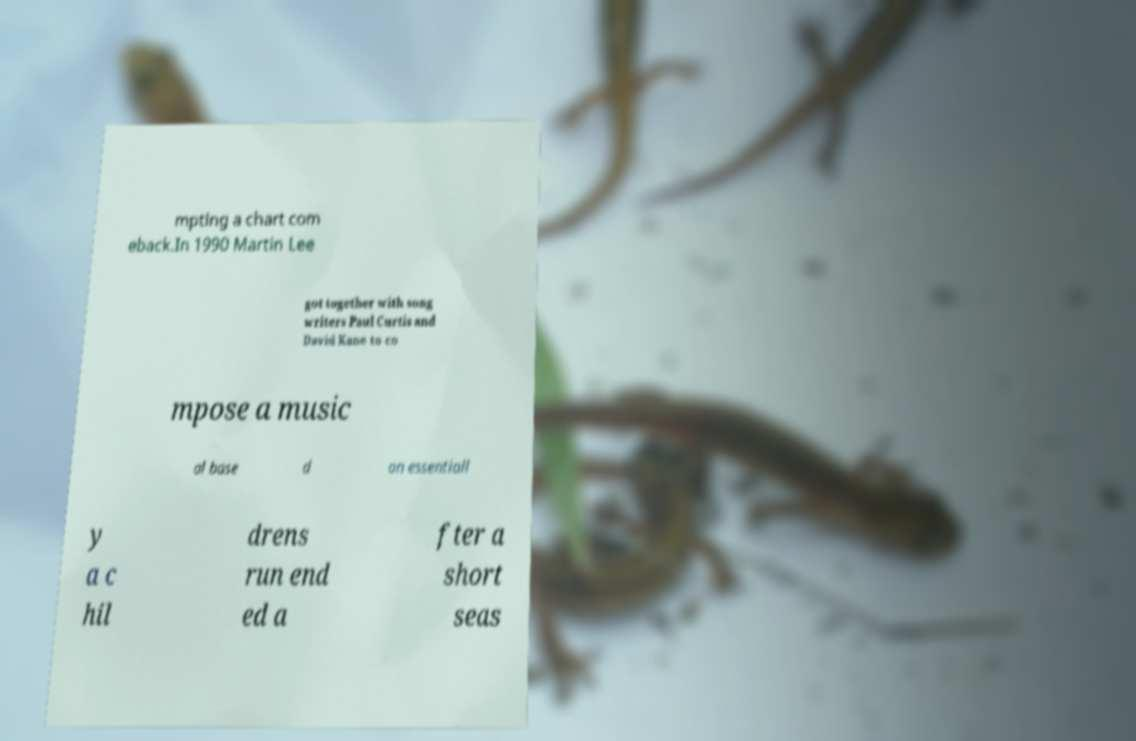Can you accurately transcribe the text from the provided image for me? mpting a chart com eback.In 1990 Martin Lee got together with song writers Paul Curtis and David Kane to co mpose a music al base d on essentiall y a c hil drens run end ed a fter a short seas 